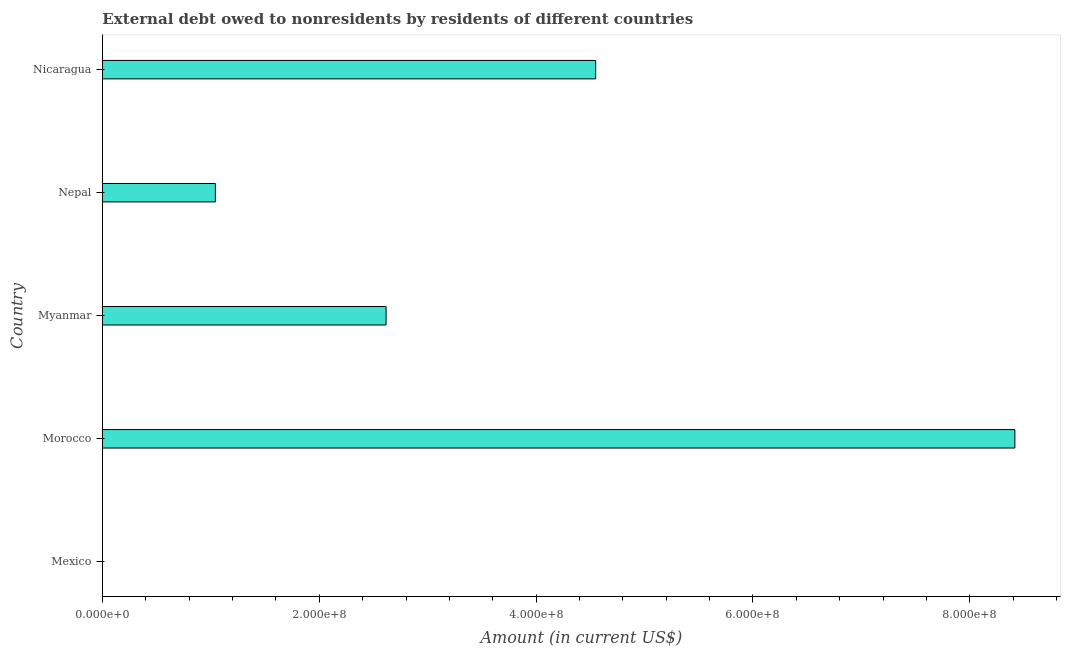Does the graph contain any zero values?
Keep it short and to the point. Yes. What is the title of the graph?
Offer a terse response. External debt owed to nonresidents by residents of different countries. What is the label or title of the Y-axis?
Your response must be concise. Country. What is the debt in Myanmar?
Your answer should be very brief. 2.62e+08. Across all countries, what is the maximum debt?
Make the answer very short. 8.42e+08. In which country was the debt maximum?
Offer a terse response. Morocco. What is the sum of the debt?
Make the answer very short. 1.66e+09. What is the difference between the debt in Morocco and Nicaragua?
Your response must be concise. 3.87e+08. What is the average debt per country?
Offer a terse response. 3.32e+08. What is the median debt?
Ensure brevity in your answer.  2.62e+08. In how many countries, is the debt greater than 520000000 US$?
Keep it short and to the point. 1. What is the ratio of the debt in Nepal to that in Nicaragua?
Provide a succinct answer. 0.23. Is the debt in Morocco less than that in Nicaragua?
Keep it short and to the point. No. Is the difference between the debt in Myanmar and Nicaragua greater than the difference between any two countries?
Provide a succinct answer. No. What is the difference between the highest and the second highest debt?
Give a very brief answer. 3.87e+08. Is the sum of the debt in Myanmar and Nepal greater than the maximum debt across all countries?
Offer a terse response. No. What is the difference between the highest and the lowest debt?
Ensure brevity in your answer.  8.42e+08. In how many countries, is the debt greater than the average debt taken over all countries?
Your response must be concise. 2. How many bars are there?
Your response must be concise. 4. Are all the bars in the graph horizontal?
Provide a succinct answer. Yes. How many countries are there in the graph?
Your response must be concise. 5. What is the difference between two consecutive major ticks on the X-axis?
Give a very brief answer. 2.00e+08. Are the values on the major ticks of X-axis written in scientific E-notation?
Your answer should be very brief. Yes. What is the Amount (in current US$) of Mexico?
Your answer should be very brief. 0. What is the Amount (in current US$) of Morocco?
Keep it short and to the point. 8.42e+08. What is the Amount (in current US$) of Myanmar?
Your response must be concise. 2.62e+08. What is the Amount (in current US$) in Nepal?
Provide a succinct answer. 1.04e+08. What is the Amount (in current US$) of Nicaragua?
Offer a very short reply. 4.55e+08. What is the difference between the Amount (in current US$) in Morocco and Myanmar?
Your response must be concise. 5.80e+08. What is the difference between the Amount (in current US$) in Morocco and Nepal?
Your response must be concise. 7.37e+08. What is the difference between the Amount (in current US$) in Morocco and Nicaragua?
Make the answer very short. 3.87e+08. What is the difference between the Amount (in current US$) in Myanmar and Nepal?
Your answer should be very brief. 1.57e+08. What is the difference between the Amount (in current US$) in Myanmar and Nicaragua?
Your response must be concise. -1.93e+08. What is the difference between the Amount (in current US$) in Nepal and Nicaragua?
Your response must be concise. -3.51e+08. What is the ratio of the Amount (in current US$) in Morocco to that in Myanmar?
Ensure brevity in your answer.  3.22. What is the ratio of the Amount (in current US$) in Morocco to that in Nepal?
Your answer should be compact. 8.08. What is the ratio of the Amount (in current US$) in Morocco to that in Nicaragua?
Keep it short and to the point. 1.85. What is the ratio of the Amount (in current US$) in Myanmar to that in Nepal?
Your answer should be very brief. 2.51. What is the ratio of the Amount (in current US$) in Myanmar to that in Nicaragua?
Make the answer very short. 0.57. What is the ratio of the Amount (in current US$) in Nepal to that in Nicaragua?
Your answer should be compact. 0.23. 